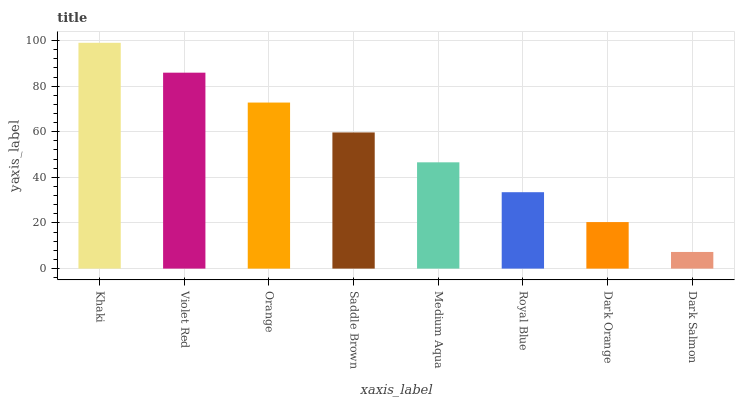Is Dark Salmon the minimum?
Answer yes or no. Yes. Is Khaki the maximum?
Answer yes or no. Yes. Is Violet Red the minimum?
Answer yes or no. No. Is Violet Red the maximum?
Answer yes or no. No. Is Khaki greater than Violet Red?
Answer yes or no. Yes. Is Violet Red less than Khaki?
Answer yes or no. Yes. Is Violet Red greater than Khaki?
Answer yes or no. No. Is Khaki less than Violet Red?
Answer yes or no. No. Is Saddle Brown the high median?
Answer yes or no. Yes. Is Medium Aqua the low median?
Answer yes or no. Yes. Is Violet Red the high median?
Answer yes or no. No. Is Violet Red the low median?
Answer yes or no. No. 